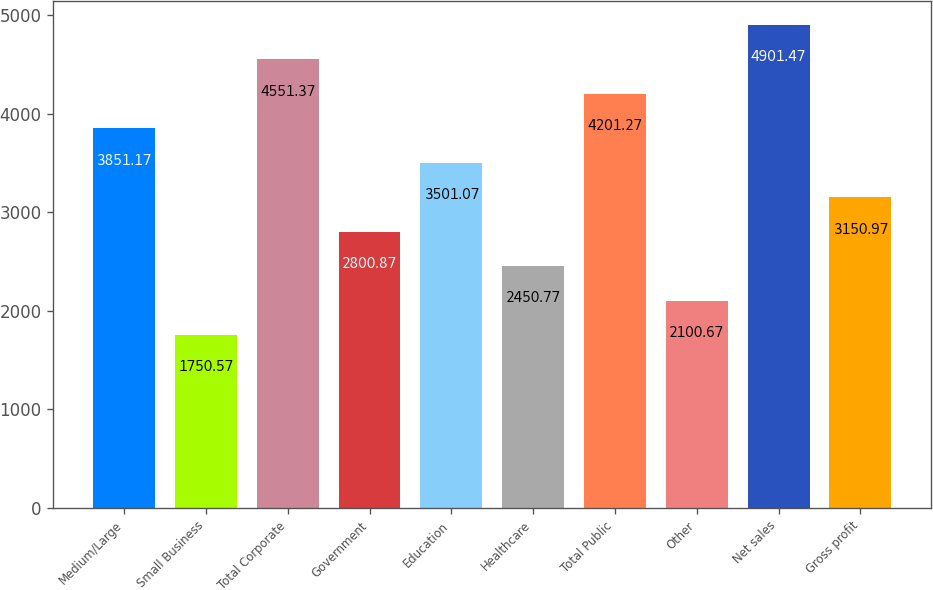<chart> <loc_0><loc_0><loc_500><loc_500><bar_chart><fcel>Medium/Large<fcel>Small Business<fcel>Total Corporate<fcel>Government<fcel>Education<fcel>Healthcare<fcel>Total Public<fcel>Other<fcel>Net sales<fcel>Gross profit<nl><fcel>3851.17<fcel>1750.57<fcel>4551.37<fcel>2800.87<fcel>3501.07<fcel>2450.77<fcel>4201.27<fcel>2100.67<fcel>4901.47<fcel>3150.97<nl></chart> 